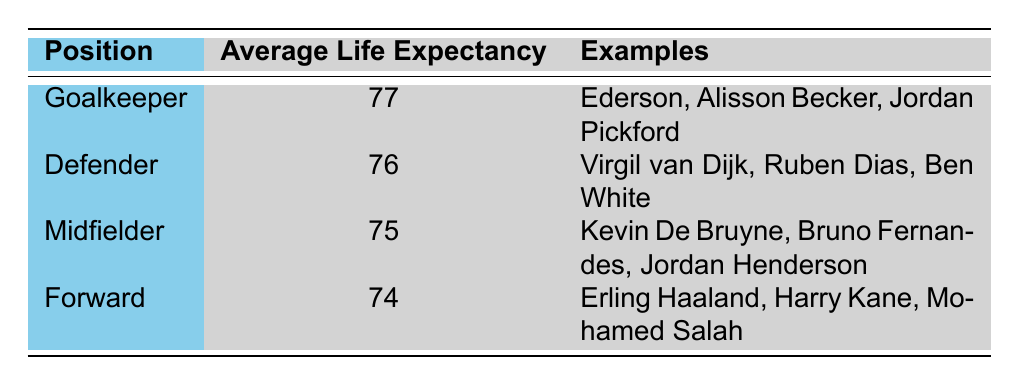What is the average life expectancy of a defender? The table specifies that the average life expectancy for a defender is 76 years.
Answer: 76 Which position has the highest average life expectancy? The table shows that goalkeepers have the highest average life expectancy at 77 years, compared to the other positions listed.
Answer: Goalkeeper Is the average life expectancy of forwards greater than that of midfielders? The average life expectancy of forwards is 74 years, while midfielders have an average of 75 years. Since 74 is less than 75, the statement is false.
Answer: No What is the combined average life expectancy of defenders and midfielders? To find the combined average, we first add the average life expectancies of defenders (76) and midfielders (75), getting 151. We then divide by the number of positions (2) to find the average: 151 / 2 = 75.5.
Answer: 75.5 Which player examples are given for midfielders? The table provides the examples of Kevin De Bruyne, Bruno Fernandes, and Jordan Henderson as midfielders.
Answer: Kevin De Bruyne, Bruno Fernandes, Jordan Henderson If you compare the average life expectancies of goalkeepers and forwards, what is the difference? The average life expectancy for goalkeepers is 77 years, and for forwards, it is 74 years. The difference is calculated as 77 - 74 = 3 years.
Answer: 3 